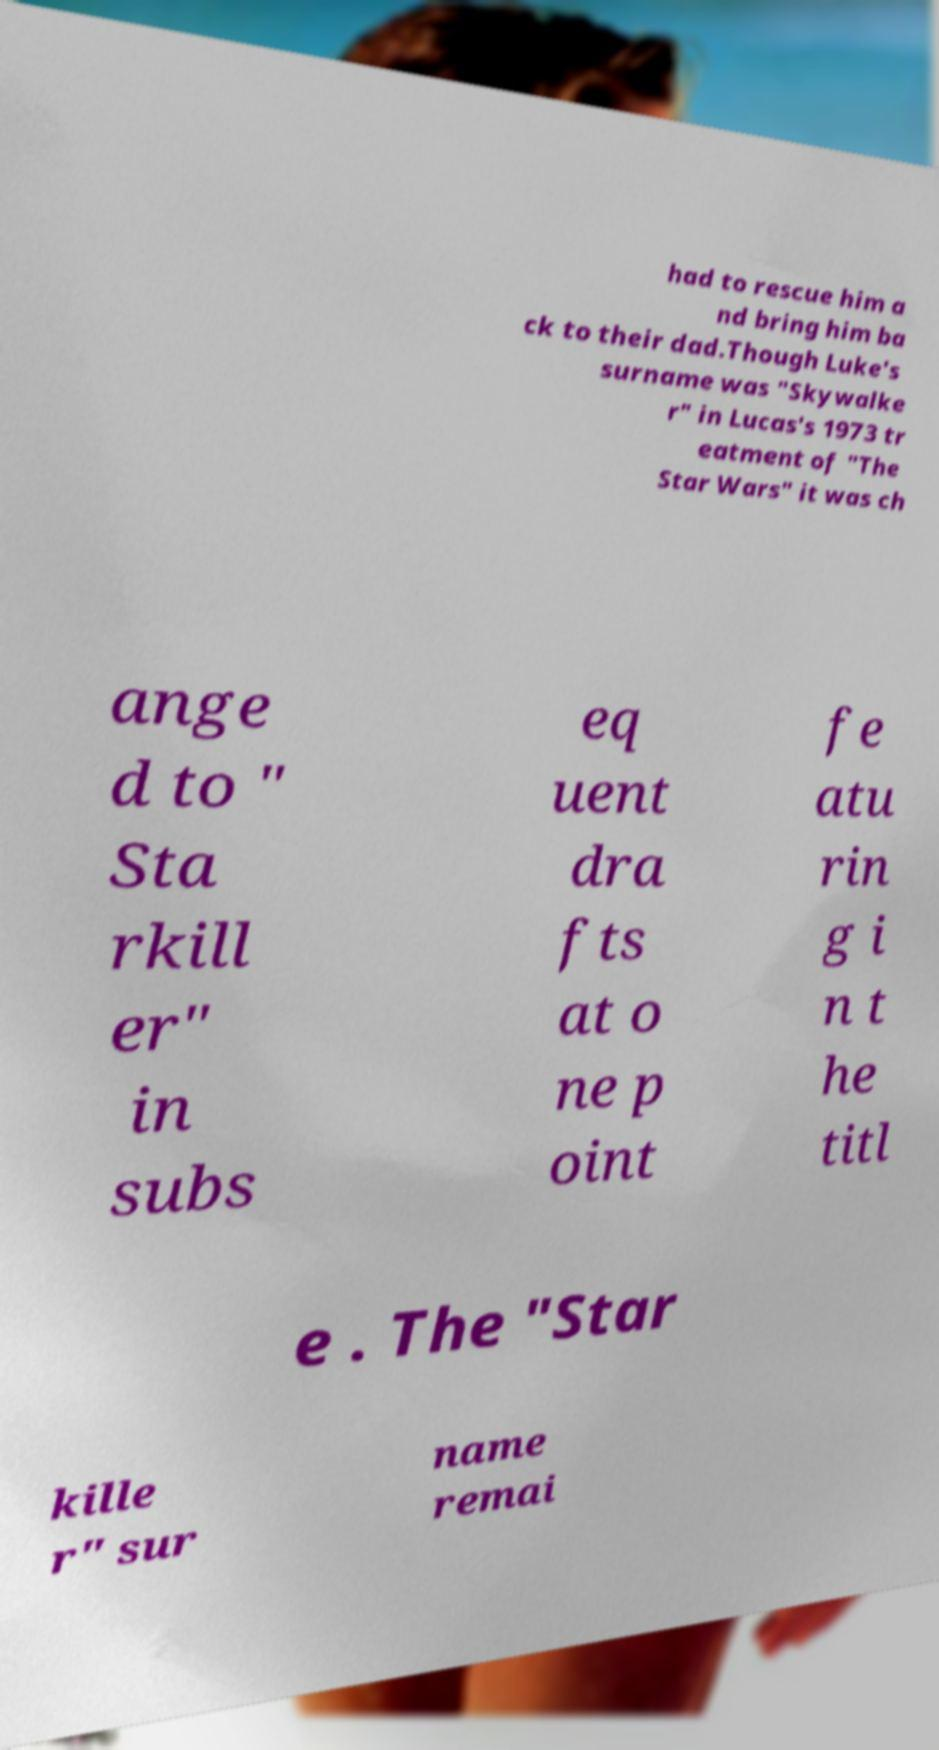I need the written content from this picture converted into text. Can you do that? had to rescue him a nd bring him ba ck to their dad.Though Luke's surname was "Skywalke r" in Lucas's 1973 tr eatment of "The Star Wars" it was ch ange d to " Sta rkill er" in subs eq uent dra fts at o ne p oint fe atu rin g i n t he titl e . The "Star kille r" sur name remai 